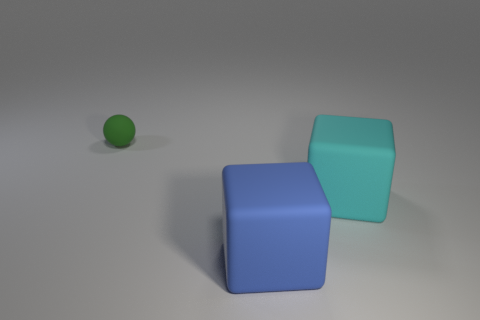Are there the same number of large rubber objects to the right of the cyan rubber cube and big rubber blocks that are to the right of the blue object?
Offer a terse response. No. Are there more big rubber blocks behind the large blue matte object than large purple metal objects?
Give a very brief answer. Yes. How many things are matte things that are on the right side of the small thing or small balls?
Offer a very short reply. 3. How many objects are the same material as the ball?
Keep it short and to the point. 2. Are there any big blue rubber things that have the same shape as the large cyan matte thing?
Your answer should be compact. Yes. There is a blue matte object that is the same size as the cyan rubber block; what is its shape?
Your answer should be compact. Cube. What number of rubber objects are on the right side of the object that is in front of the cyan rubber cube?
Your answer should be very brief. 1. There is a object that is both to the left of the cyan block and behind the blue rubber block; what is its size?
Give a very brief answer. Small. Are there any rubber blocks of the same size as the cyan object?
Make the answer very short. Yes. Is the number of blue matte cubes that are in front of the tiny matte ball greater than the number of small things that are on the right side of the big blue rubber cube?
Make the answer very short. Yes. 